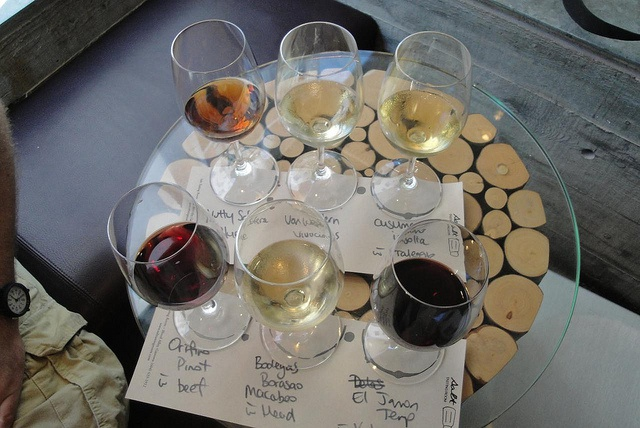Describe the objects in this image and their specific colors. I can see wine glass in white, darkgray, gray, tan, and black tones, bench in white, black, and gray tones, people in white, gray, and black tones, wine glass in white, darkgray, black, gray, and maroon tones, and wine glass in white, darkgray, gray, and olive tones in this image. 